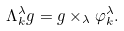<formula> <loc_0><loc_0><loc_500><loc_500>\Lambda _ { k } ^ { \lambda } g = g \times _ { \lambda } \varphi _ { k } ^ { \lambda } .</formula> 